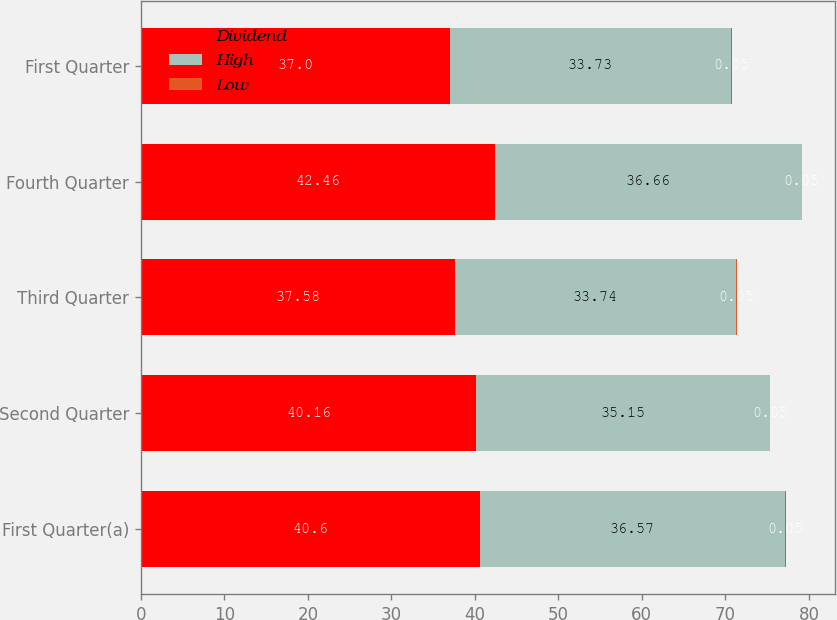Convert chart to OTSL. <chart><loc_0><loc_0><loc_500><loc_500><stacked_bar_chart><ecel><fcel>First Quarter(a)<fcel>Second Quarter<fcel>Third Quarter<fcel>Fourth Quarter<fcel>First Quarter<nl><fcel>Dividend<fcel>40.6<fcel>40.16<fcel>37.58<fcel>42.46<fcel>37<nl><fcel>High<fcel>36.57<fcel>35.15<fcel>33.74<fcel>36.66<fcel>33.73<nl><fcel>Low<fcel>0.05<fcel>0.05<fcel>0.05<fcel>0.05<fcel>0.05<nl></chart> 